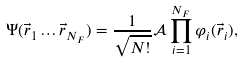Convert formula to latex. <formula><loc_0><loc_0><loc_500><loc_500>\Psi ( \vec { r } _ { 1 } \dots \vec { r } _ { { N } _ { F } } ) = \frac { 1 } { \sqrt { N ! } } { \mathcal { A } } \prod _ { i = 1 } ^ { N _ { F } } \varphi _ { i } ( \vec { r } _ { i } ) ,</formula> 